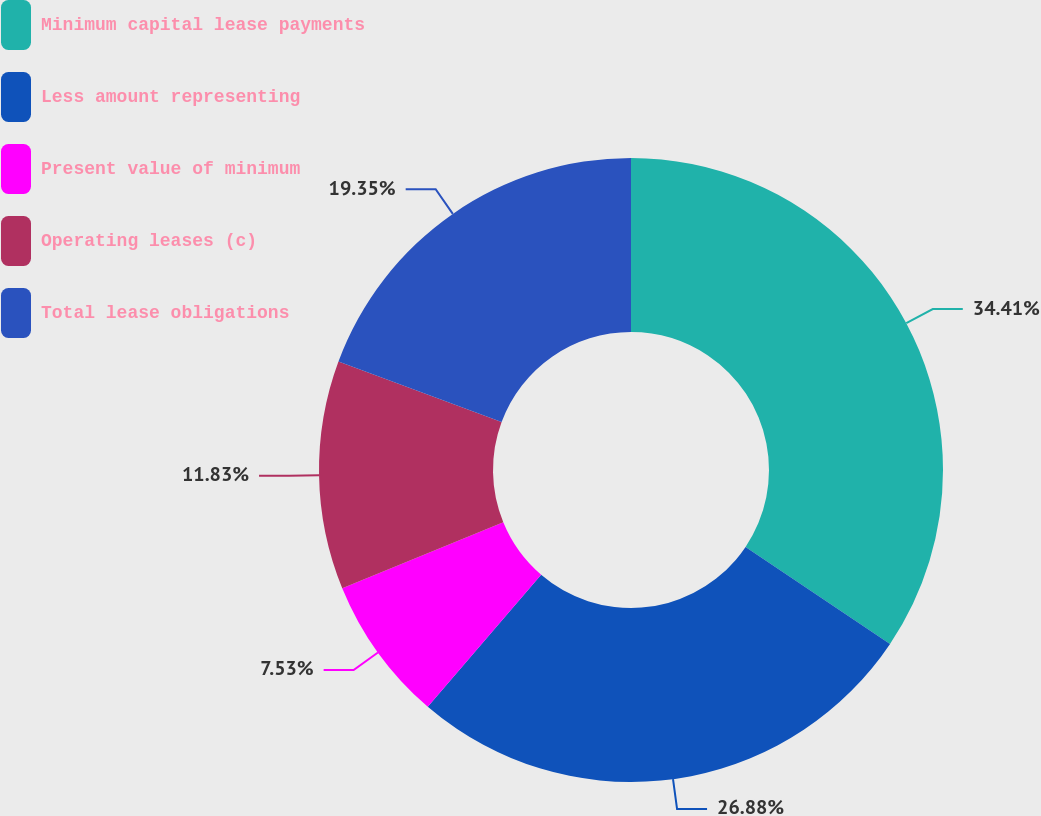Convert chart to OTSL. <chart><loc_0><loc_0><loc_500><loc_500><pie_chart><fcel>Minimum capital lease payments<fcel>Less amount representing<fcel>Present value of minimum<fcel>Operating leases (c)<fcel>Total lease obligations<nl><fcel>34.41%<fcel>26.88%<fcel>7.53%<fcel>11.83%<fcel>19.35%<nl></chart> 